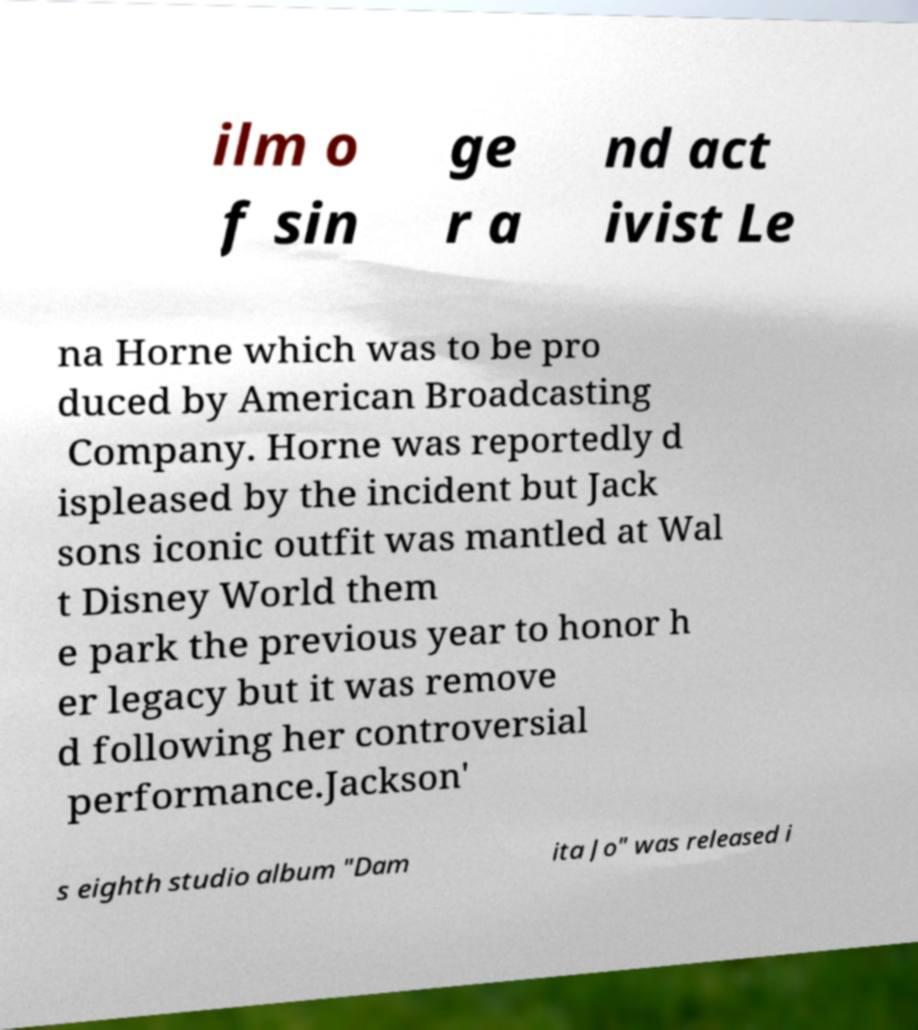What messages or text are displayed in this image? I need them in a readable, typed format. ilm o f sin ge r a nd act ivist Le na Horne which was to be pro duced by American Broadcasting Company. Horne was reportedly d ispleased by the incident but Jack sons iconic outfit was mantled at Wal t Disney World them e park the previous year to honor h er legacy but it was remove d following her controversial performance.Jackson' s eighth studio album "Dam ita Jo" was released i 